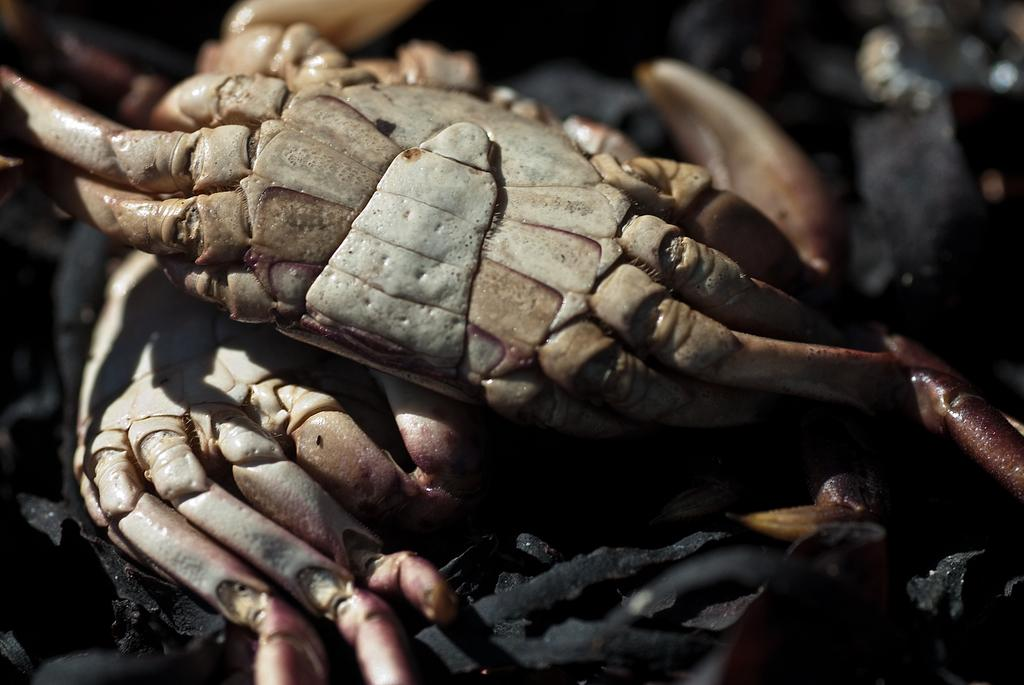What creatures can be seen in the image? There are two crabs in the image. What can be found on the ground in the image? There are black objects on the ground in the image. How would you describe the background of the image? The background of the image is blurred. What type of credit can be seen being offered in the image? There is no credit or financial information present in the image; it features two crabs and black objects on the ground. Can you see any fangs on the crabs in the image? Crabs do not have fangs, so there are no fangs visible on the crabs in the image. 